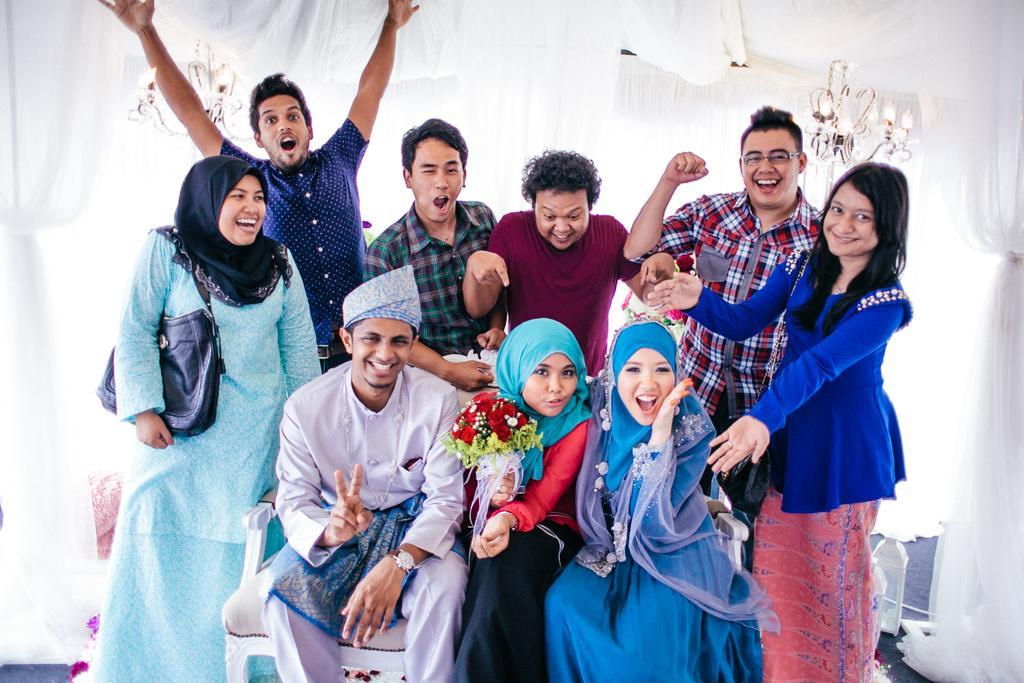Describe this image in one or two sentences. In this image, in the middle, we can see three people are sitting on the chair. In the background, we can see a group of people are standing, we can also see white color in the background. 